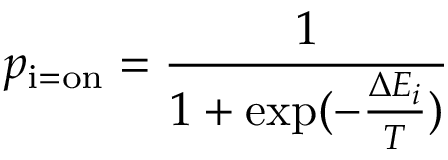<formula> <loc_0><loc_0><loc_500><loc_500>p _ { i = o n } = { \frac { 1 } { 1 + \exp ( - { \frac { \Delta E _ { i } } { T } } ) } }</formula> 